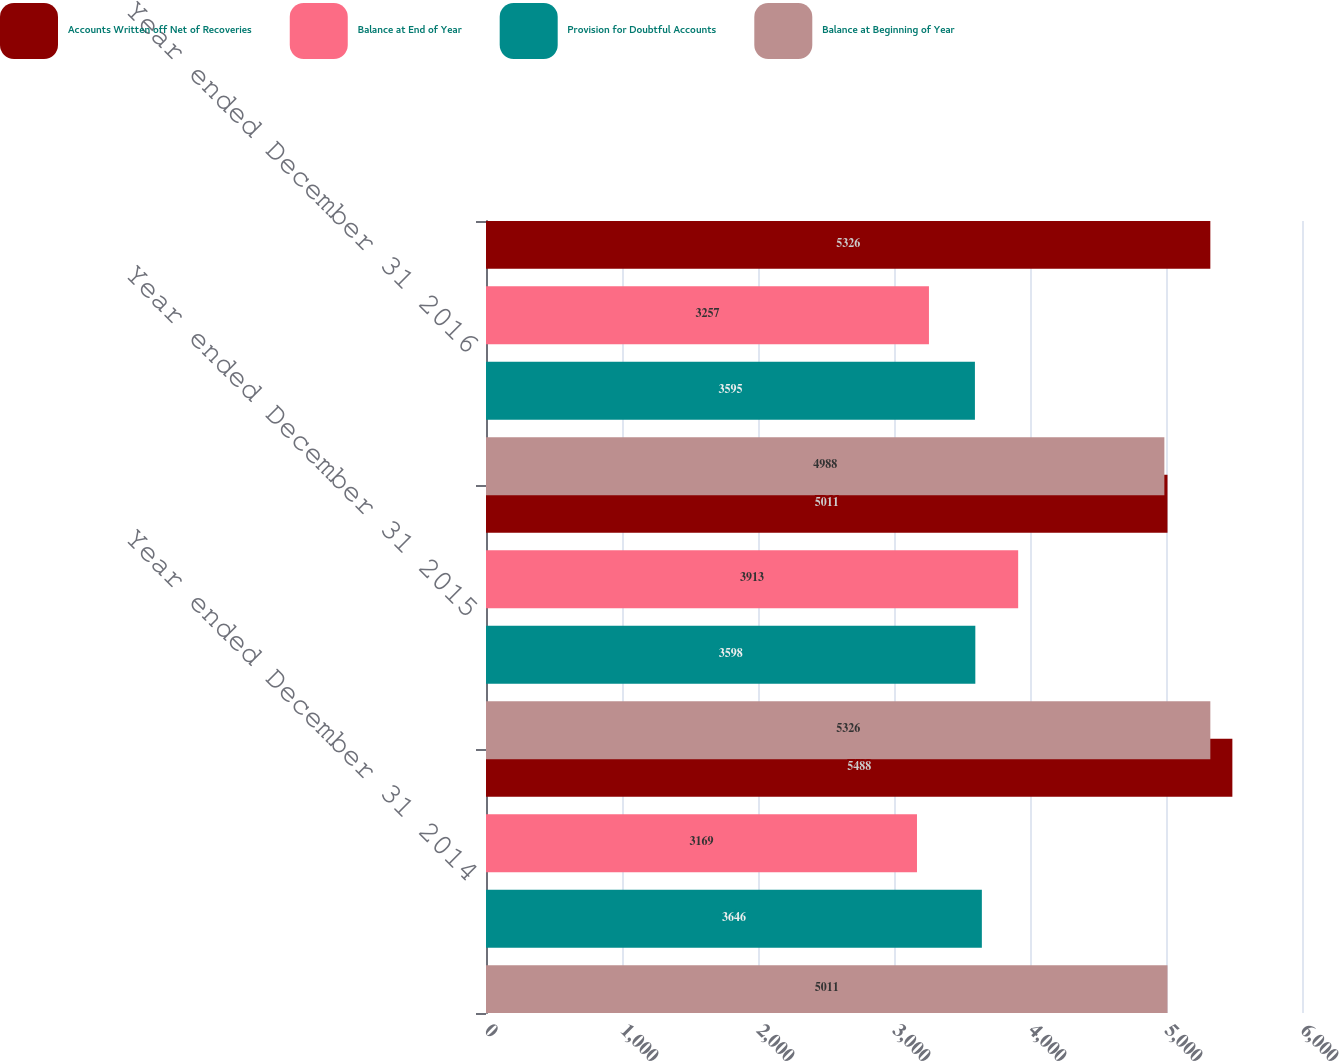<chart> <loc_0><loc_0><loc_500><loc_500><stacked_bar_chart><ecel><fcel>Year ended December 31 2014<fcel>Year ended December 31 2015<fcel>Year ended December 31 2016<nl><fcel>Accounts Written off Net of Recoveries<fcel>5488<fcel>5011<fcel>5326<nl><fcel>Balance at End of Year<fcel>3169<fcel>3913<fcel>3257<nl><fcel>Provision for Doubtful Accounts<fcel>3646<fcel>3598<fcel>3595<nl><fcel>Balance at Beginning of Year<fcel>5011<fcel>5326<fcel>4988<nl></chart> 